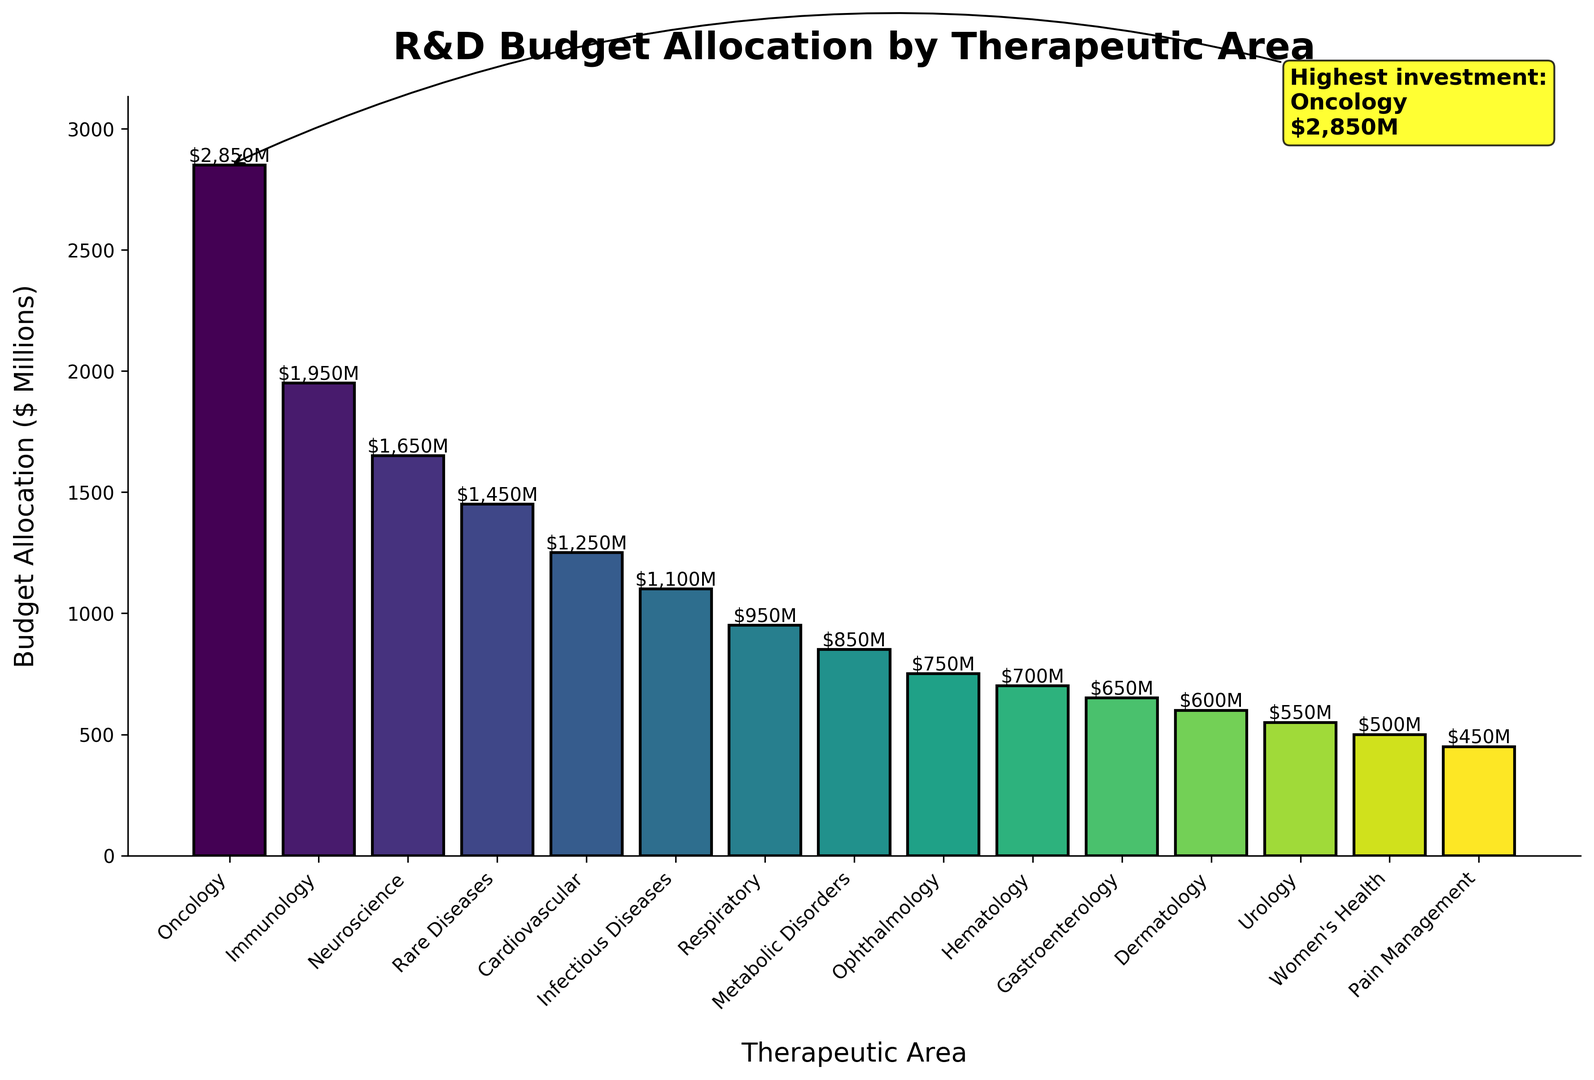Which therapeutic area received the highest investment? The annotation indicates the highest investment is in Oncology with $2,850M.
Answer: Oncology What is the difference in budget allocation between Oncology and Infectious Diseases? Oncology has $2,850M and Infectious Diseases have $1,100M. The difference is $2,850M - $1,100M = $1,750M.
Answer: $1,750M How many therapeutic areas have a budget allocation of at least $1,000M? Areas with at least $1,000M are Oncology, Immunology, Neuroscience, Rare Diseases, Cardiovascular, and Infectious Diseases. This totals to six areas.
Answer: 6 Which therapeutic area received the least budget allocation? The bar corresponding to Women’s Health is the shortest and has a budget allocation of $500M.
Answer: Women’s Health What is the combined budget allocation for Oncology and Immunology? Oncology has $2,850M and Immunology has $1,950M. Their combined budget is $2,850M + $1,950M = $4,800M.
Answer: $4,800M Compare the total budget allocation of Metabolic Disorders and Gastroenterology. Which is greater? Metabolic Disorders have $850M and Gastroenterology has $650M. Metabolic Disorders have a greater budget allocation.
Answer: Metabolic Disorders What is the average budget allocation of the top three therapeutic areas? The top three areas are Oncology ($2,850M), Immunology ($1,950M), and Neuroscience ($1,650M). The average is ($2,850M + $1,950M + $1,650M) / 3 = $2,150M.
Answer: $2,150M Is the budget allocation for Respiratory higher or lower than the allocation for Hematology? Respiratory has a budget allocation of $950M, while Hematology has $700M. Respiratory's allocation is higher.
Answer: Higher Which therapeutic areas have budget allocations greater than the median allocation? With 15 areas, the median is the 8th value when sorted. Median is Respiratory at $950M. Areas greater than Respiratory are Oncology, Immunology, Neuroscience, Rare Diseases, Cardiovascular, and Infectious Diseases.
Answer: Oncology, Immunology, Neuroscience, Rare Diseases, Cardiovascular, Infectious Diseases What is the total budget allocation for all therapeutic areas? Sum of all budget allocations is $2,850M + $1,950M + $1,650M + $1,450M + $1,250M + $1,100M + $950M + $850M + $750M + $700M + $650M + $600M + $550M + $500M + $450M = $16,300M.
Answer: $16,300M 